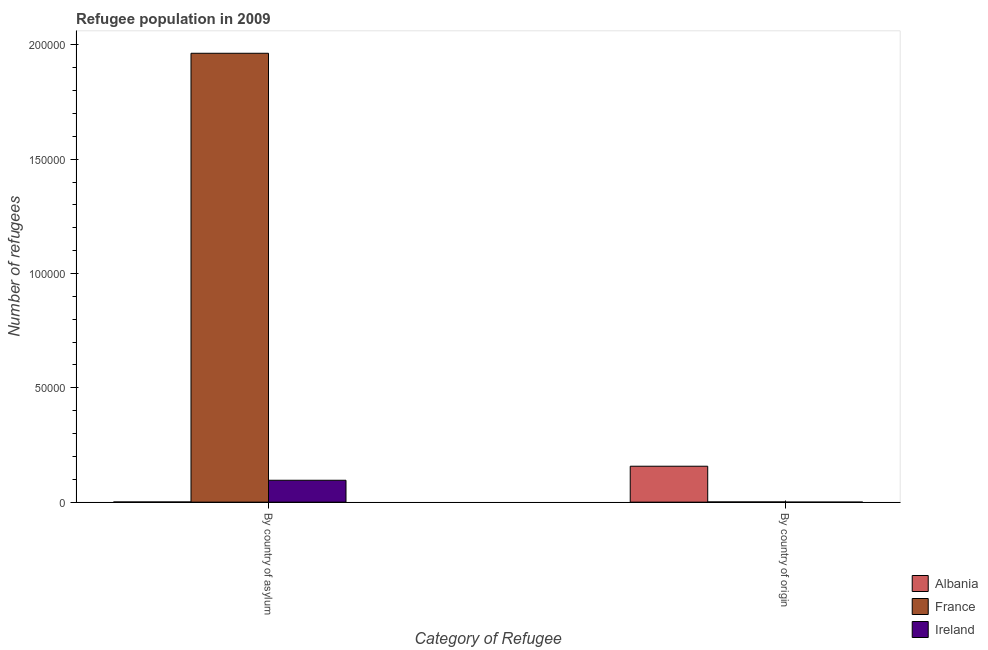How many different coloured bars are there?
Ensure brevity in your answer.  3. What is the label of the 2nd group of bars from the left?
Make the answer very short. By country of origin. What is the number of refugees by country of asylum in Ireland?
Provide a short and direct response. 9571. Across all countries, what is the maximum number of refugees by country of asylum?
Offer a terse response. 1.96e+05. Across all countries, what is the minimum number of refugees by country of origin?
Provide a succinct answer. 7. In which country was the number of refugees by country of origin minimum?
Make the answer very short. Ireland. What is the total number of refugees by country of origin in the graph?
Your response must be concise. 1.58e+04. What is the difference between the number of refugees by country of origin in Ireland and that in Albania?
Give a very brief answer. -1.57e+04. What is the difference between the number of refugees by country of asylum in Albania and the number of refugees by country of origin in Ireland?
Provide a succinct answer. 63. What is the average number of refugees by country of asylum per country?
Offer a terse response. 6.87e+04. What is the difference between the number of refugees by country of asylum and number of refugees by country of origin in France?
Your answer should be compact. 1.96e+05. In how many countries, is the number of refugees by country of origin greater than 70000 ?
Provide a short and direct response. 0. What is the ratio of the number of refugees by country of origin in Ireland to that in France?
Your answer should be very brief. 0.08. What does the 1st bar from the left in By country of origin represents?
Offer a very short reply. Albania. What does the 1st bar from the right in By country of origin represents?
Provide a succinct answer. Ireland. How many bars are there?
Offer a terse response. 6. Are all the bars in the graph horizontal?
Offer a terse response. No. How many countries are there in the graph?
Give a very brief answer. 3. Are the values on the major ticks of Y-axis written in scientific E-notation?
Give a very brief answer. No. Does the graph contain any zero values?
Provide a short and direct response. No. Does the graph contain grids?
Give a very brief answer. No. Where does the legend appear in the graph?
Offer a very short reply. Bottom right. How many legend labels are there?
Ensure brevity in your answer.  3. What is the title of the graph?
Ensure brevity in your answer.  Refugee population in 2009. Does "Egypt, Arab Rep." appear as one of the legend labels in the graph?
Offer a terse response. No. What is the label or title of the X-axis?
Offer a terse response. Category of Refugee. What is the label or title of the Y-axis?
Ensure brevity in your answer.  Number of refugees. What is the Number of refugees of France in By country of asylum?
Provide a short and direct response. 1.96e+05. What is the Number of refugees in Ireland in By country of asylum?
Offer a terse response. 9571. What is the Number of refugees in Albania in By country of origin?
Your answer should be compact. 1.57e+04. What is the Number of refugees in France in By country of origin?
Offer a terse response. 87. What is the Number of refugees of Ireland in By country of origin?
Offer a terse response. 7. Across all Category of Refugee, what is the maximum Number of refugees in Albania?
Provide a short and direct response. 1.57e+04. Across all Category of Refugee, what is the maximum Number of refugees in France?
Give a very brief answer. 1.96e+05. Across all Category of Refugee, what is the maximum Number of refugees of Ireland?
Provide a succinct answer. 9571. Across all Category of Refugee, what is the minimum Number of refugees of Albania?
Offer a very short reply. 70. Across all Category of Refugee, what is the minimum Number of refugees of Ireland?
Your answer should be very brief. 7. What is the total Number of refugees of Albania in the graph?
Offer a terse response. 1.58e+04. What is the total Number of refugees in France in the graph?
Provide a short and direct response. 1.96e+05. What is the total Number of refugees in Ireland in the graph?
Make the answer very short. 9578. What is the difference between the Number of refugees of Albania in By country of asylum and that in By country of origin?
Ensure brevity in your answer.  -1.56e+04. What is the difference between the Number of refugees in France in By country of asylum and that in By country of origin?
Offer a terse response. 1.96e+05. What is the difference between the Number of refugees of Ireland in By country of asylum and that in By country of origin?
Provide a succinct answer. 9564. What is the difference between the Number of refugees in France in By country of asylum and the Number of refugees in Ireland in By country of origin?
Keep it short and to the point. 1.96e+05. What is the average Number of refugees in Albania per Category of Refugee?
Keep it short and to the point. 7890.5. What is the average Number of refugees of France per Category of Refugee?
Make the answer very short. 9.82e+04. What is the average Number of refugees of Ireland per Category of Refugee?
Your answer should be very brief. 4789. What is the difference between the Number of refugees in Albania and Number of refugees in France in By country of asylum?
Ensure brevity in your answer.  -1.96e+05. What is the difference between the Number of refugees in Albania and Number of refugees in Ireland in By country of asylum?
Your answer should be compact. -9501. What is the difference between the Number of refugees in France and Number of refugees in Ireland in By country of asylum?
Offer a very short reply. 1.87e+05. What is the difference between the Number of refugees of Albania and Number of refugees of France in By country of origin?
Offer a very short reply. 1.56e+04. What is the difference between the Number of refugees of Albania and Number of refugees of Ireland in By country of origin?
Offer a terse response. 1.57e+04. What is the ratio of the Number of refugees in Albania in By country of asylum to that in By country of origin?
Offer a terse response. 0. What is the ratio of the Number of refugees in France in By country of asylum to that in By country of origin?
Offer a terse response. 2257.06. What is the ratio of the Number of refugees of Ireland in By country of asylum to that in By country of origin?
Make the answer very short. 1367.29. What is the difference between the highest and the second highest Number of refugees in Albania?
Your response must be concise. 1.56e+04. What is the difference between the highest and the second highest Number of refugees in France?
Your answer should be very brief. 1.96e+05. What is the difference between the highest and the second highest Number of refugees of Ireland?
Make the answer very short. 9564. What is the difference between the highest and the lowest Number of refugees in Albania?
Give a very brief answer. 1.56e+04. What is the difference between the highest and the lowest Number of refugees of France?
Provide a succinct answer. 1.96e+05. What is the difference between the highest and the lowest Number of refugees of Ireland?
Offer a terse response. 9564. 